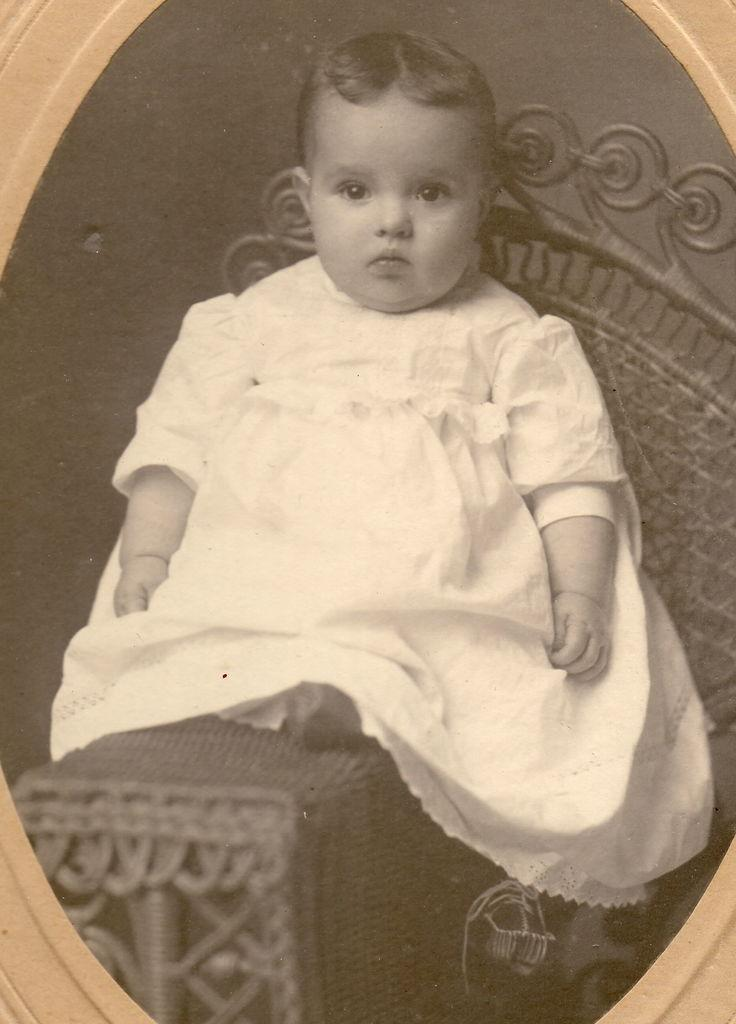What is the main subject of the image? The main subject of the image is a baby. What is the baby doing in the image? The baby is sitting on a chair in the image. What riddle is the baby trying to solve in the image? There is no riddle present in the image; the baby is simply sitting on a chair. 